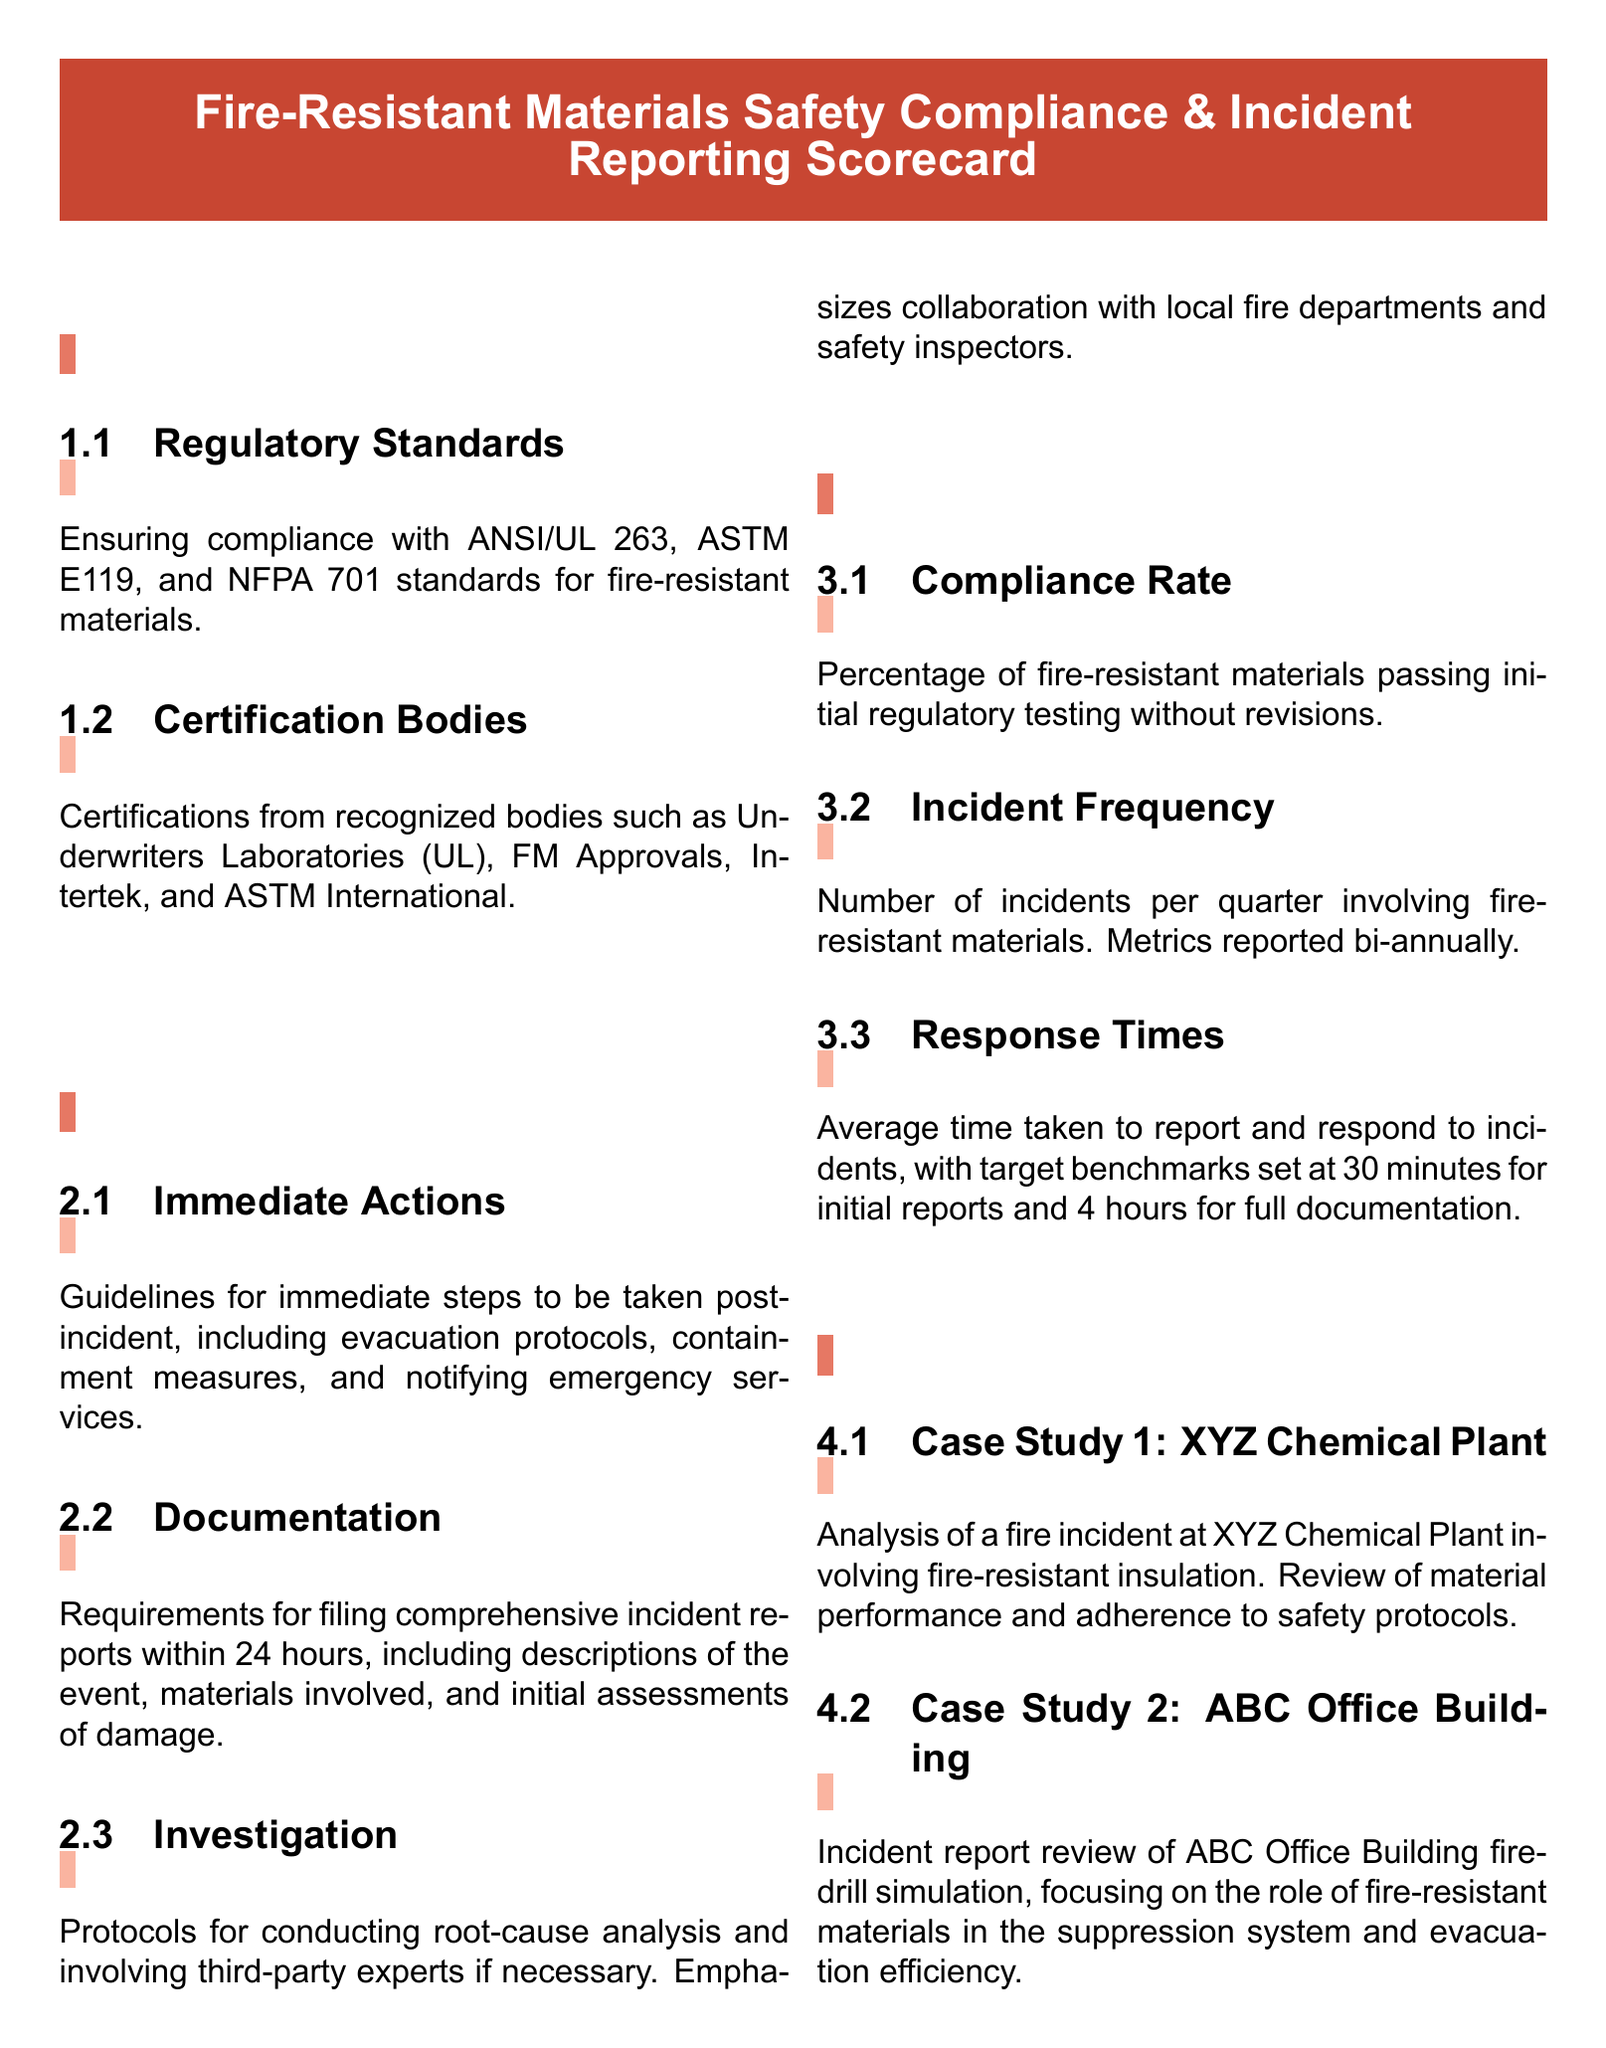What are the regulatory standards for fire-resistant materials? The regulatory standards listed in the document are ANSI/UL 263, ASTM E119, and NFPA 701.
Answer: ANSI/UL 263, ASTM E119, and NFPA 701 What is the certification body mentioned for fire-resistant materials? The document mentions Underwriters Laboratories (UL), FM Approvals, Intertek, and ASTM International as certification bodies.
Answer: Underwriters Laboratories (UL) What is the average target response time for full documentation? The document specifies a target benchmark of 4 hours for full documentation following an incident.
Answer: 4 hours How often are incident metrics reported? Incidents involving fire-resistant materials are reported bi-annually, as noted in the metrics section.
Answer: bi-annually What percentage is the compliance rate for fire-resistant materials? The compliance rate is expressed as a percentage of materials passing initial regulatory testing without revisions, but the exact percentage is not specified in the document.
Answer: Not specified What is the focus of the case study involving ABC Office Building? The case study focuses on the role of fire-resistant materials in the suppression system and evacuation efficiency during a fire-drill simulation.
Answer: Fire-drill simulation, suppression system What does the immediate actions section cover? It includes guidelines for evacuation protocols, containment measures, and notifying emergency services post-incident.
Answer: Evacuation protocols, containment measures What is the requirement for filing incident reports? The document requires that comprehensive incident reports be filed within 24 hours.
Answer: 24 hours What is the incident frequency metric? The incident frequency metric records the number of incidents per quarter involving fire-resistant materials.
Answer: Number of incidents per quarter 